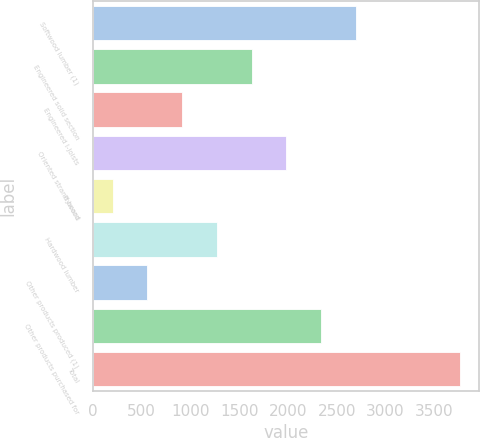Convert chart. <chart><loc_0><loc_0><loc_500><loc_500><bar_chart><fcel>Softwood lumber (1)<fcel>Engineered solid section<fcel>Engineered I-joists<fcel>Oriented strand board<fcel>Plywood<fcel>Hardwood lumber<fcel>Other products produced (1)<fcel>Other products purchased for<fcel>Total<nl><fcel>2698.2<fcel>1628.4<fcel>915.2<fcel>1985<fcel>202<fcel>1271.8<fcel>558.6<fcel>2341.6<fcel>3768<nl></chart> 